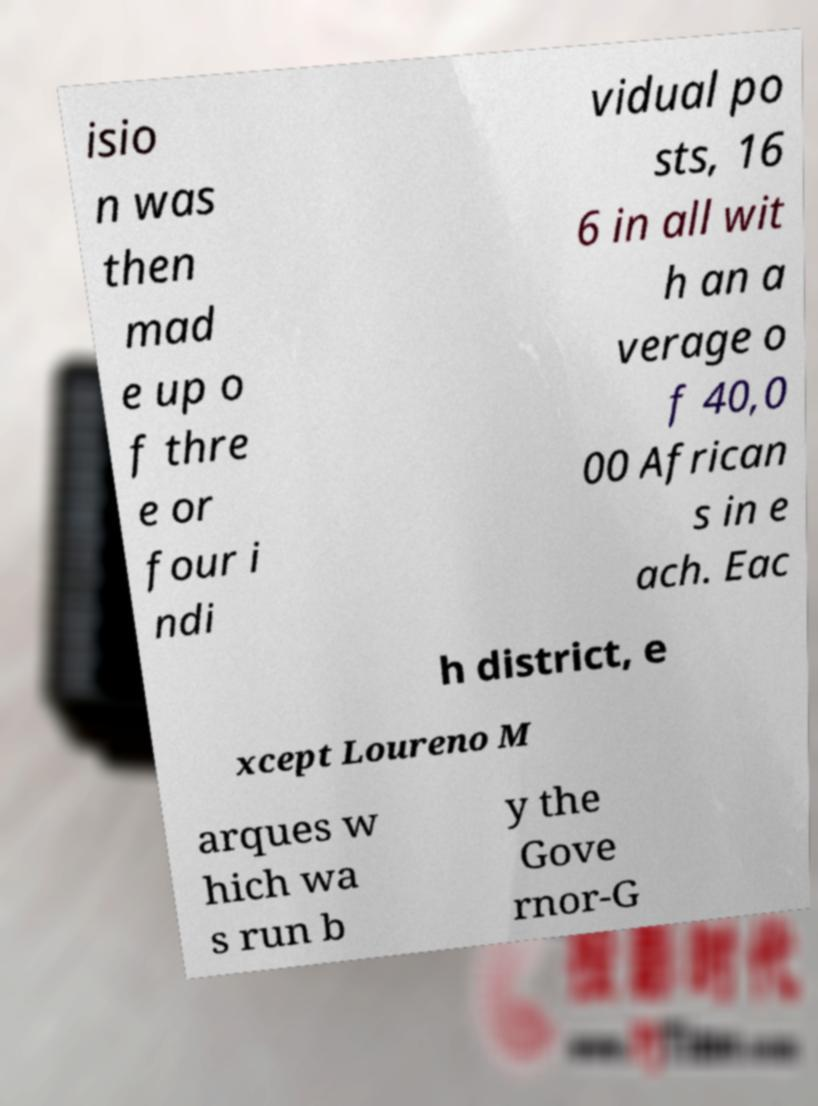Can you accurately transcribe the text from the provided image for me? isio n was then mad e up o f thre e or four i ndi vidual po sts, 16 6 in all wit h an a verage o f 40,0 00 African s in e ach. Eac h district, e xcept Loureno M arques w hich wa s run b y the Gove rnor-G 